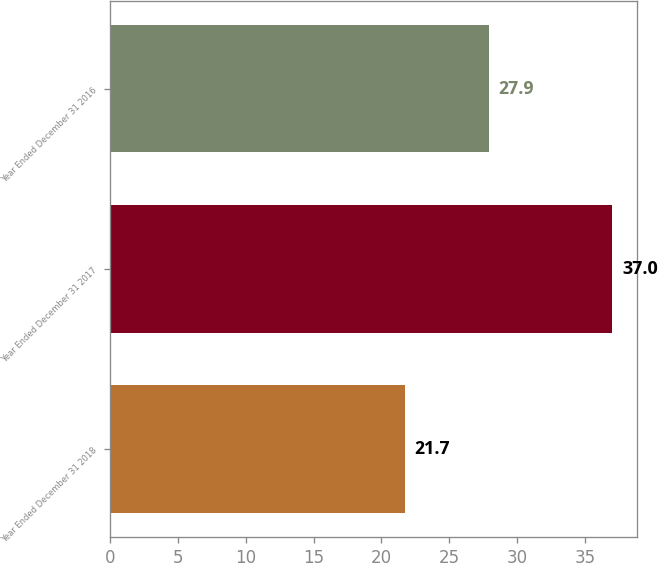<chart> <loc_0><loc_0><loc_500><loc_500><bar_chart><fcel>Year Ended December 31 2018<fcel>Year Ended December 31 2017<fcel>Year Ended December 31 2016<nl><fcel>21.7<fcel>37<fcel>27.9<nl></chart> 